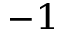Convert formula to latex. <formula><loc_0><loc_0><loc_500><loc_500>^ { - 1 }</formula> 